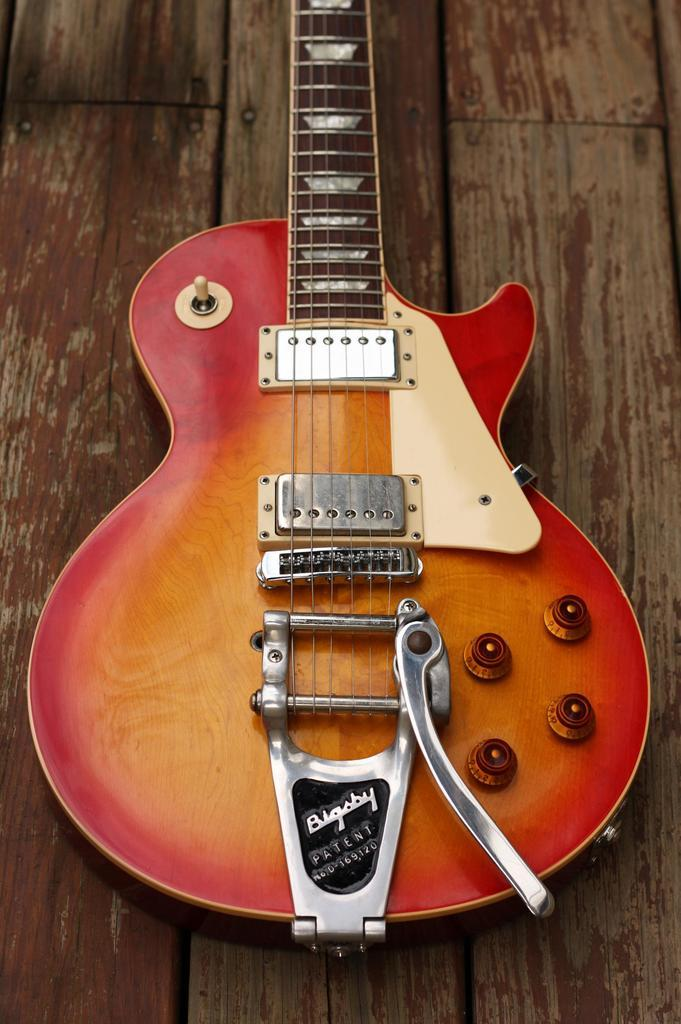What musical instrument is present in the image? There is a guitar in the image. Where is the guitar placed? The guitar is on a wooden plank. What type of pen is used to write the notes on the wooden plank? There is no pen or writing present on the wooden plank in the image. 